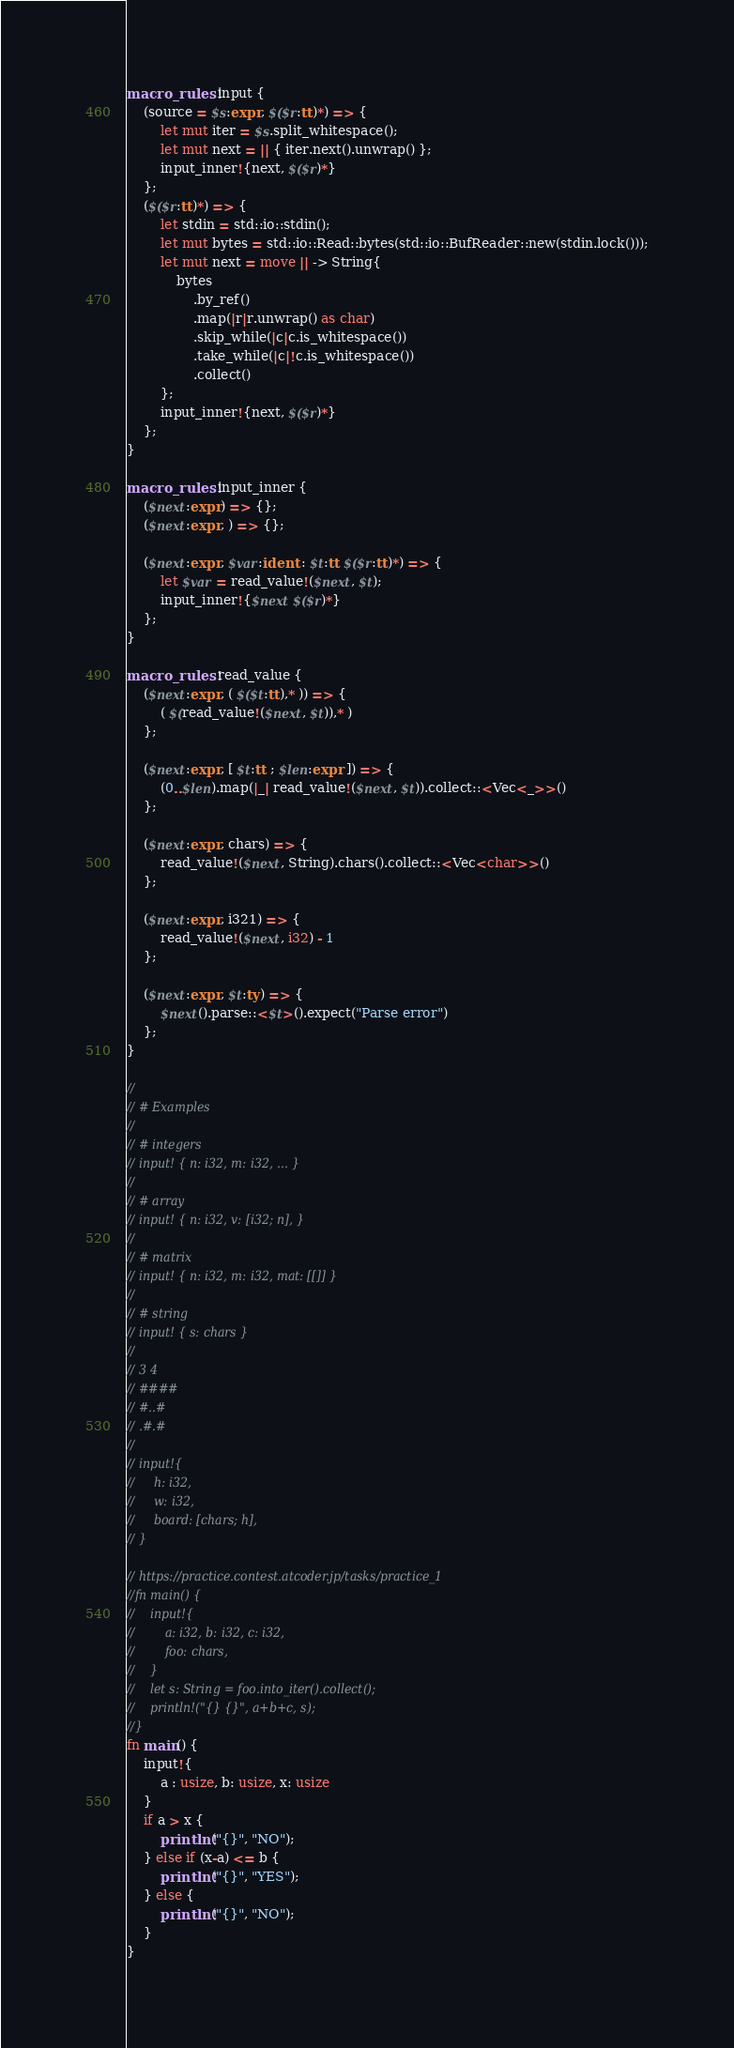<code> <loc_0><loc_0><loc_500><loc_500><_Rust_>macro_rules! input {
    (source = $s:expr, $($r:tt)*) => {
        let mut iter = $s.split_whitespace();
        let mut next = || { iter.next().unwrap() };
        input_inner!{next, $($r)*}
    };
    ($($r:tt)*) => {
        let stdin = std::io::stdin();
        let mut bytes = std::io::Read::bytes(std::io::BufReader::new(stdin.lock()));
        let mut next = move || -> String{
            bytes
                .by_ref()
                .map(|r|r.unwrap() as char)
                .skip_while(|c|c.is_whitespace())
                .take_while(|c|!c.is_whitespace())
                .collect()
        };
        input_inner!{next, $($r)*}
    };
}

macro_rules! input_inner {
    ($next:expr) => {};
    ($next:expr, ) => {};

    ($next:expr, $var:ident : $t:tt $($r:tt)*) => {
        let $var = read_value!($next, $t);
        input_inner!{$next $($r)*}
    };
}

macro_rules! read_value {
    ($next:expr, ( $($t:tt),* )) => {
        ( $(read_value!($next, $t)),* )
    };

    ($next:expr, [ $t:tt ; $len:expr ]) => {
        (0..$len).map(|_| read_value!($next, $t)).collect::<Vec<_>>()
    };

    ($next:expr, chars) => {
        read_value!($next, String).chars().collect::<Vec<char>>()
    };

    ($next:expr, i321) => {
        read_value!($next, i32) - 1
    };

    ($next:expr, $t:ty) => {
        $next().parse::<$t>().expect("Parse error")
    };
}

//
// # Examples
//
// # integers
// input! { n: i32, m: i32, ... }
//
// # array
// input! { n: i32, v: [i32; n], }
//
// # matrix
// input! { n: i32, m: i32, mat: [[]] }
//
// # string
// input! { s: chars }
//
// 3 4
// ####
// #..#
// .#.#
//
// input!{
//     h: i32,
//     w: i32,
//     board: [chars; h],
// }

// https://practice.contest.atcoder.jp/tasks/practice_1
//fn main() {
//    input!{
//        a: i32, b: i32, c: i32,
//        foo: chars,
//    }
//    let s: String = foo.into_iter().collect();
//    println!("{} {}", a+b+c, s);
//}
fn main() {
    input!{
        a : usize, b: usize, x: usize
    }
    if a > x {
        println!("{}", "NO");
    } else if (x-a) <= b {
        println!("{}", "YES");
    } else {
        println!("{}", "NO");
    }
}</code> 